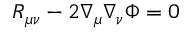Convert formula to latex. <formula><loc_0><loc_0><loc_500><loc_500>R _ { \mu \nu } - 2 \nabla _ { \mu } \nabla _ { \nu } \Phi = 0</formula> 